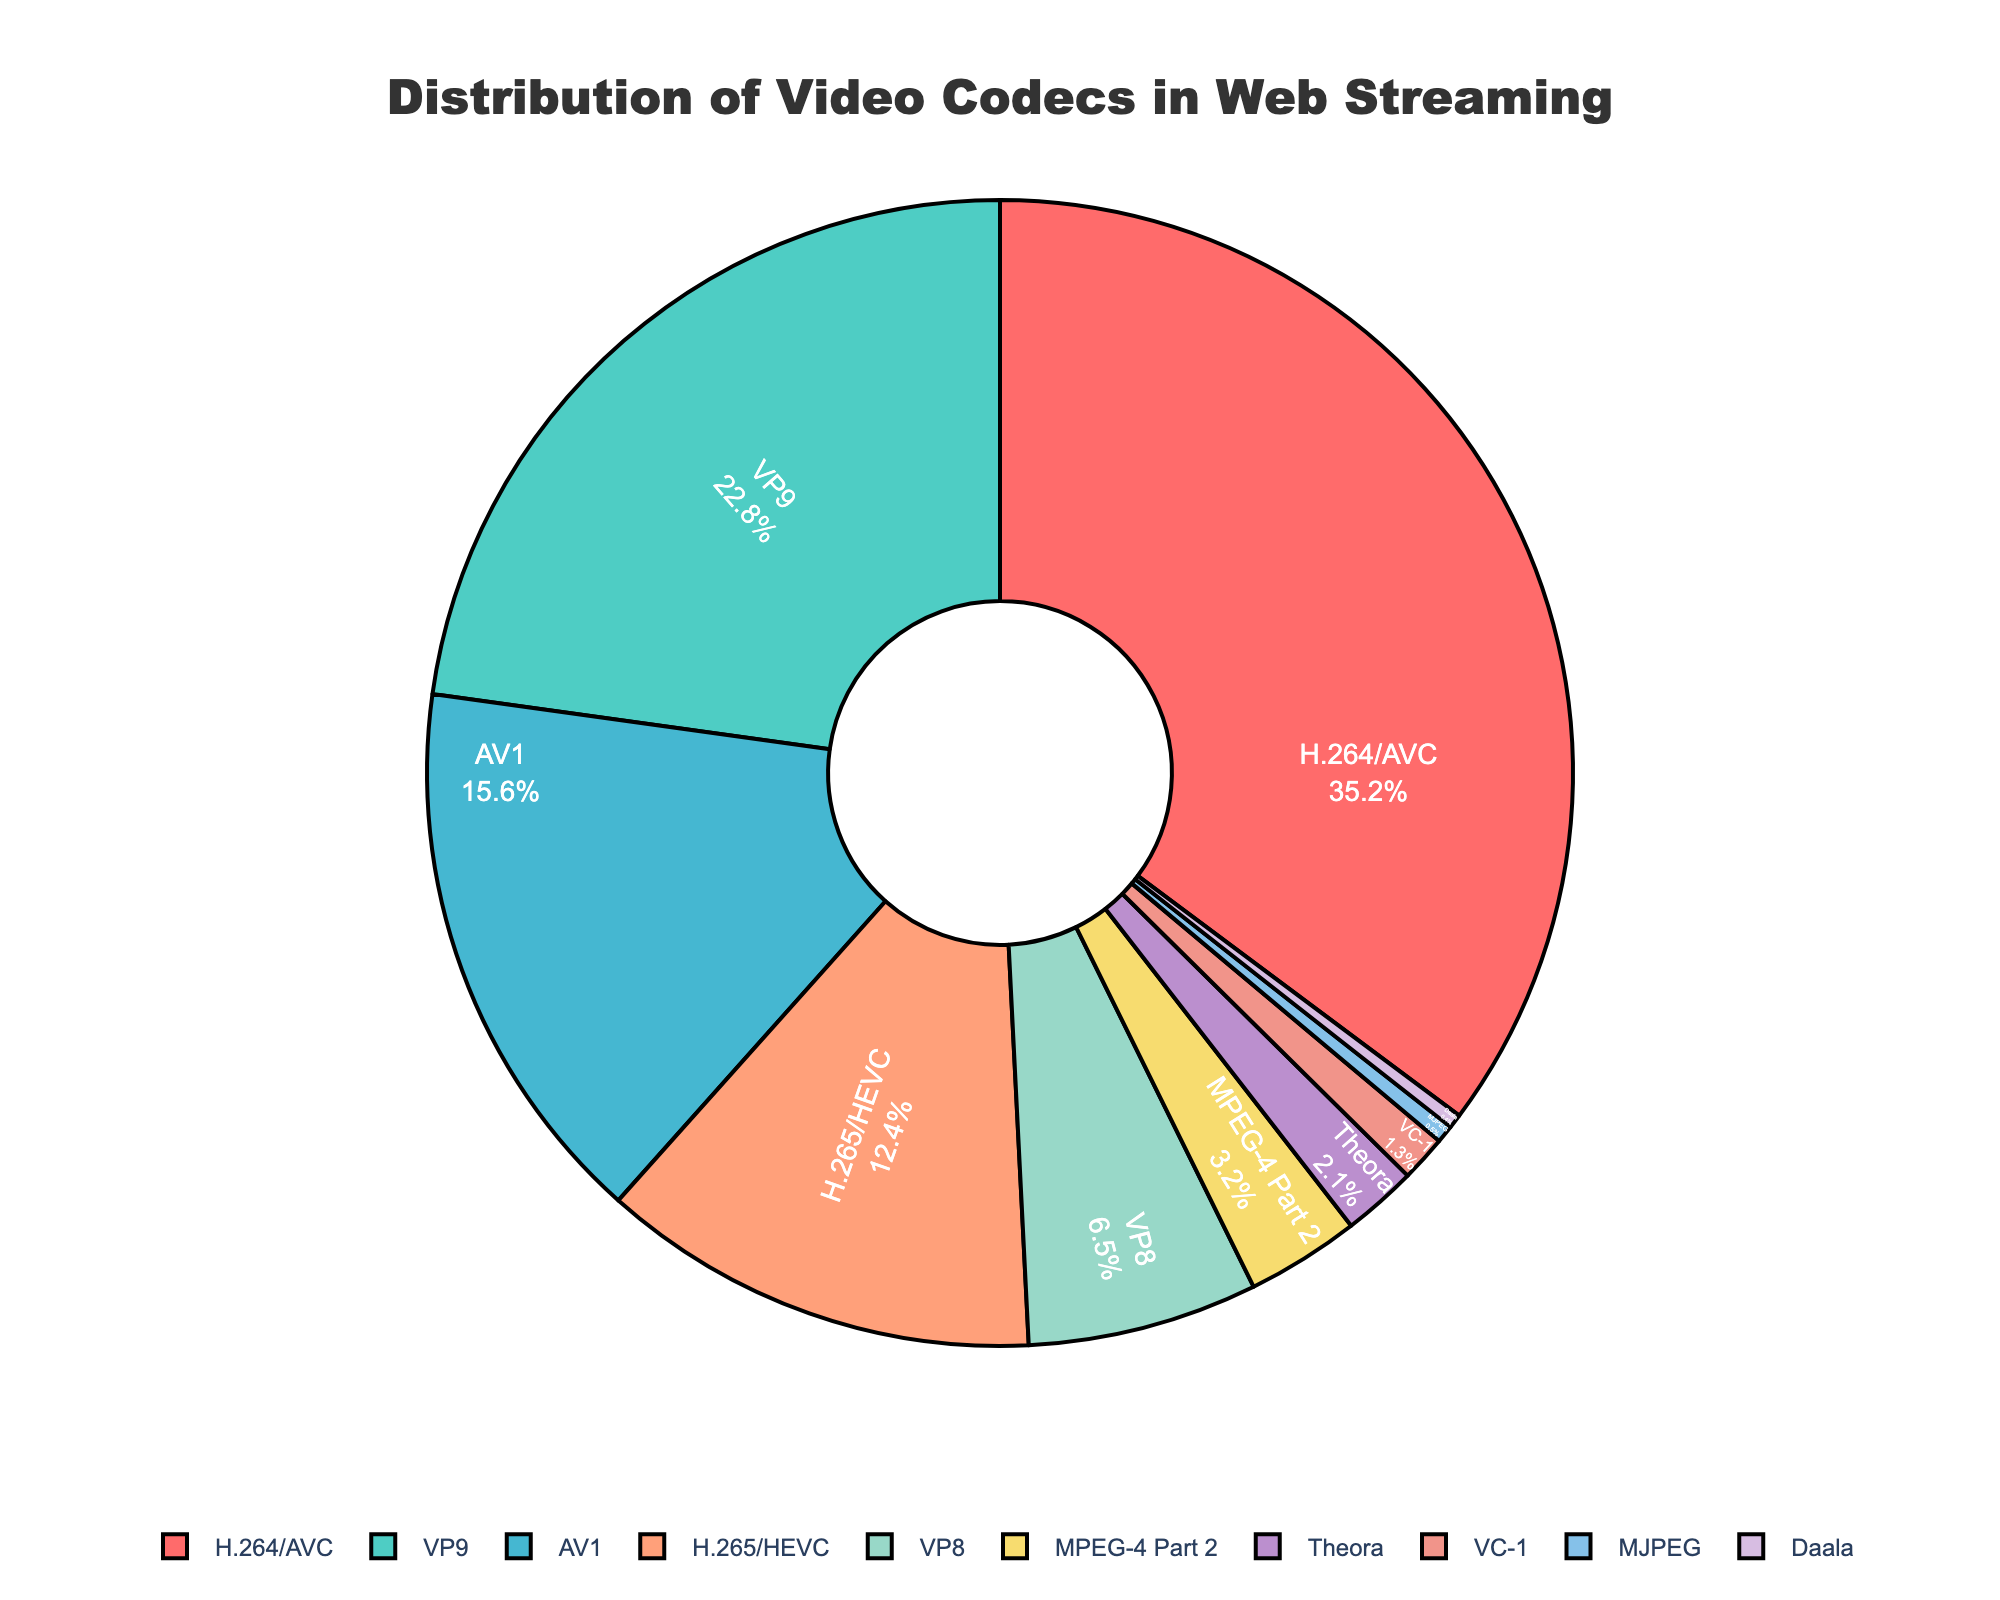Which codec has the highest percentage? To determine the codec with the highest percentage, look at the pie chart. The segment with the label "H.264/AVC" represents 35.2%, which is the largest among all segments.
Answer: H.264/AVC Which two codecs together represent more than 50% of the distribution? Add the percentages of the two largest segments: H.264/AVC (35.2%) and VP9 (22.8%). The sum is 35.2 + 22.8 = 58.0%, which is more than 50%.
Answer: H.264/AVC and VP9 What is the combined percentage of the least used three codecs? Identify the three segments with the smallest percentages: Daala (0.4%), MJPEG (0.5%), and VC-1 (1.3%). Add these percentages: 0.4 + 0.5 + 1.3 = 2.2%.
Answer: 2.2% Is the usage of AV1 higher or lower than H.265/HEVC? Compare the percentages of AV1 (15.6%) and H.265/HEVC (12.4%). Since 15.6% is greater than 12.4%, AV1 is used more than H.265/HEVC.
Answer: Higher Which codec segment is represented in green? Refer to the visual attribute, the segment represented by green is the second largest by area, which corresponds to VP9 with 22.8%.
Answer: VP9 What percentage range do most codecs fall into? Examine the distribution of the percentages. Most of the codecs fall between the 1% to 7% range.
Answer: 1% to 7% What is the total percentage of MPEG-4 Part 2, Theora, and VC-1 combined? Add the individual percentages for these codecs: MPEG-4 Part 2 (3.2%), Theora (2.1%), and VC-1 (1.3%). The sum is 3.2 + 2.1 + 1.3 = 6.6%.
Answer: 6.6% How does the percentage of VP8 compare to the percentage of AV1? Compare the percentages of VP8 (6.5%) and AV1 (15.6%). Since 6.5% is less than 15.6%, VP8 has a lower percentage than AV1.
Answer: Lower What is the overall percentage for all the codecs other than H.264/AVC and VP9? Subtract the combined percentage of H.264/AVC and VP9 from 100%. H.264/AVC is 35.2% and VP9 is 22.8%, so 100 - (35.2 + 22.8) = 42.0%.
Answer: 42.0% 